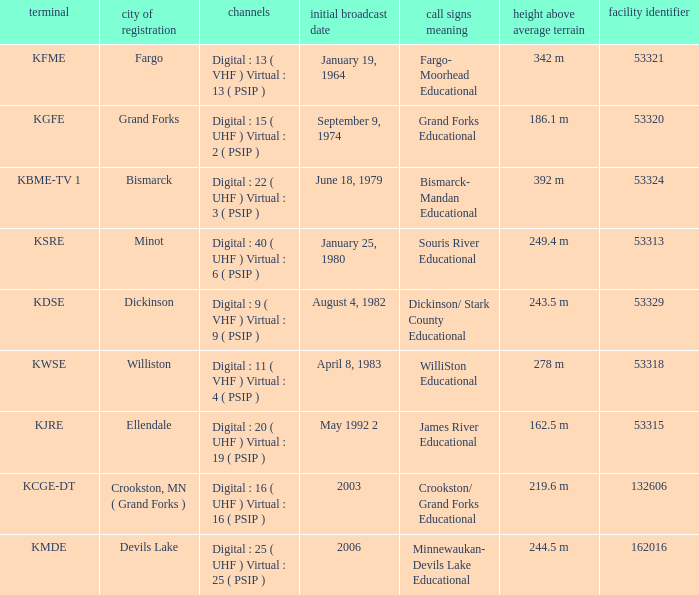What is the haat of devils lake 244.5 m. Parse the table in full. {'header': ['terminal', 'city of registration', 'channels', 'initial broadcast date', 'call signs meaning', 'height above average terrain', 'facility identifier'], 'rows': [['KFME', 'Fargo', 'Digital : 13 ( VHF ) Virtual : 13 ( PSIP )', 'January 19, 1964', 'Fargo- Moorhead Educational', '342 m', '53321'], ['KGFE', 'Grand Forks', 'Digital : 15 ( UHF ) Virtual : 2 ( PSIP )', 'September 9, 1974', 'Grand Forks Educational', '186.1 m', '53320'], ['KBME-TV 1', 'Bismarck', 'Digital : 22 ( UHF ) Virtual : 3 ( PSIP )', 'June 18, 1979', 'Bismarck- Mandan Educational', '392 m', '53324'], ['KSRE', 'Minot', 'Digital : 40 ( UHF ) Virtual : 6 ( PSIP )', 'January 25, 1980', 'Souris River Educational', '249.4 m', '53313'], ['KDSE', 'Dickinson', 'Digital : 9 ( VHF ) Virtual : 9 ( PSIP )', 'August 4, 1982', 'Dickinson/ Stark County Educational', '243.5 m', '53329'], ['KWSE', 'Williston', 'Digital : 11 ( VHF ) Virtual : 4 ( PSIP )', 'April 8, 1983', 'WilliSton Educational', '278 m', '53318'], ['KJRE', 'Ellendale', 'Digital : 20 ( UHF ) Virtual : 19 ( PSIP )', 'May 1992 2', 'James River Educational', '162.5 m', '53315'], ['KCGE-DT', 'Crookston, MN ( Grand Forks )', 'Digital : 16 ( UHF ) Virtual : 16 ( PSIP )', '2003', 'Crookston/ Grand Forks Educational', '219.6 m', '132606'], ['KMDE', 'Devils Lake', 'Digital : 25 ( UHF ) Virtual : 25 ( PSIP )', '2006', 'Minnewaukan- Devils Lake Educational', '244.5 m', '162016']]} 